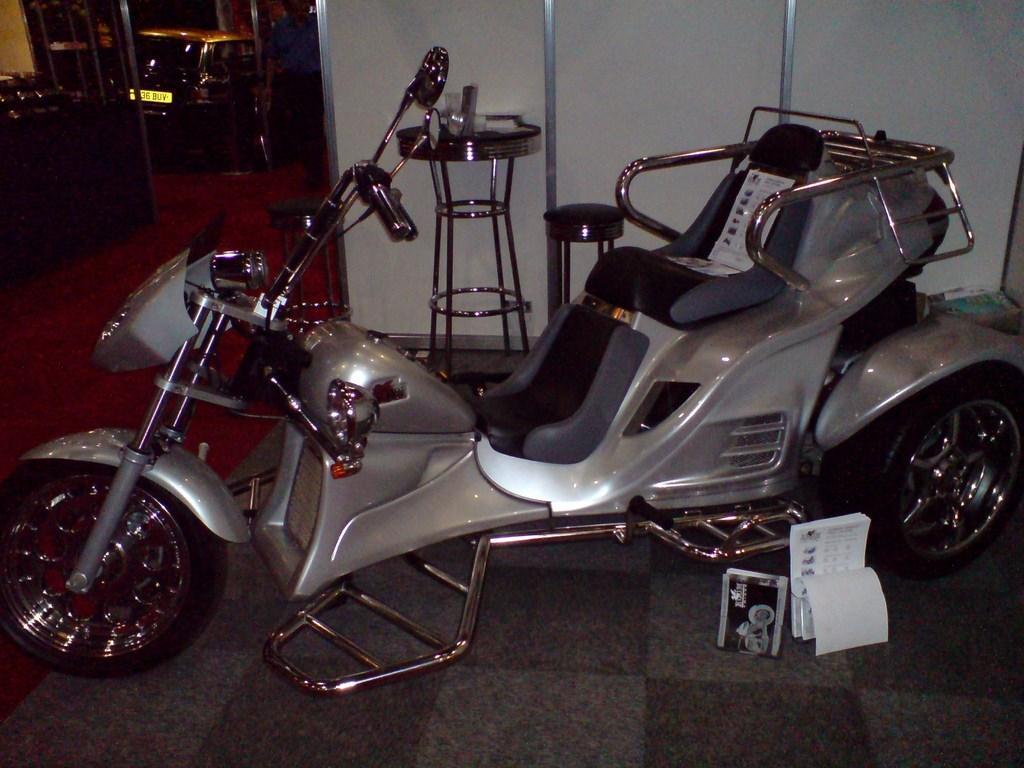Please provide a concise description of this image. In this image in the center there is a vehicle, and in the background there are stools, board and vehicles and some objects. At the bottom there is carpet and floor. 